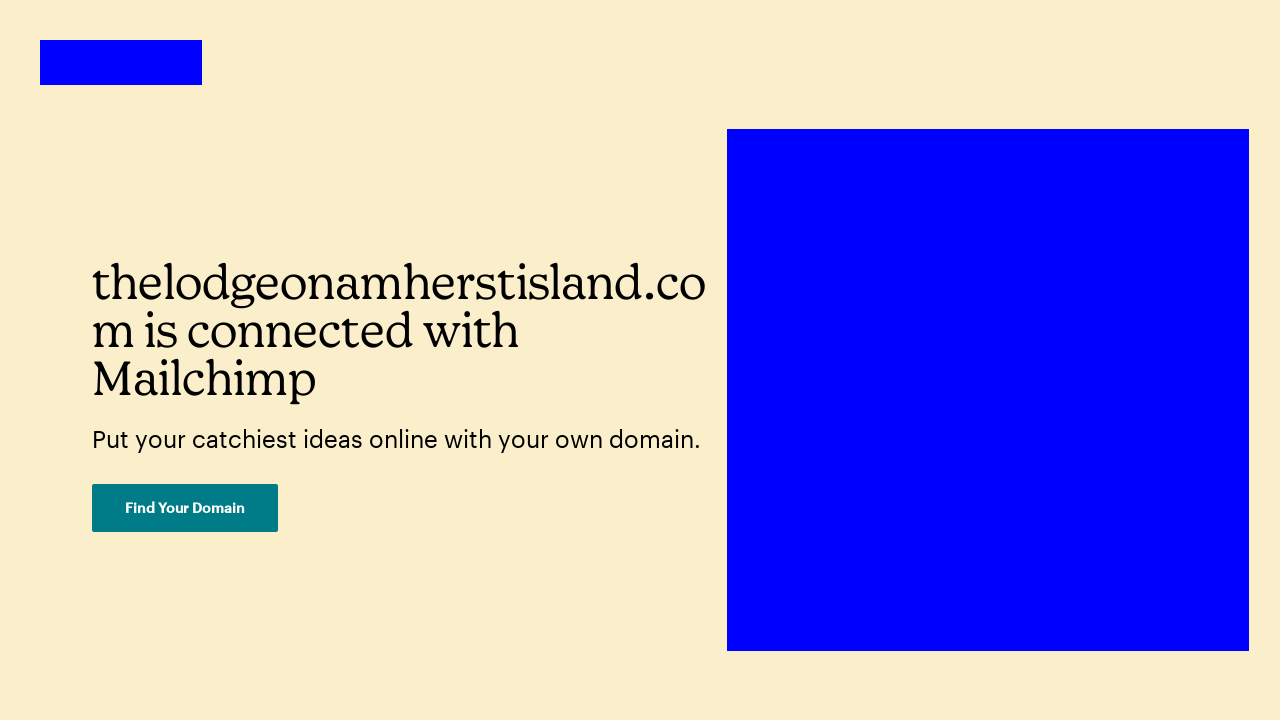How is typography utilized in this design to influence viewer perception? Typography in this design is used strategically to convey clarity and modernity. The use of bold, large letters for the main heading establishes authority and draws attention. The sans-serif font contributes to a clean and contemporary feel, suitable for technology-oriented content. The varying sizes and weights of the text help to create a hierarchy, guiding the viewer's eye from the most important element (the headline) to supplementary information (the description and button). This organization aids in effective communication and impacts how users perceive the site's purpose. 